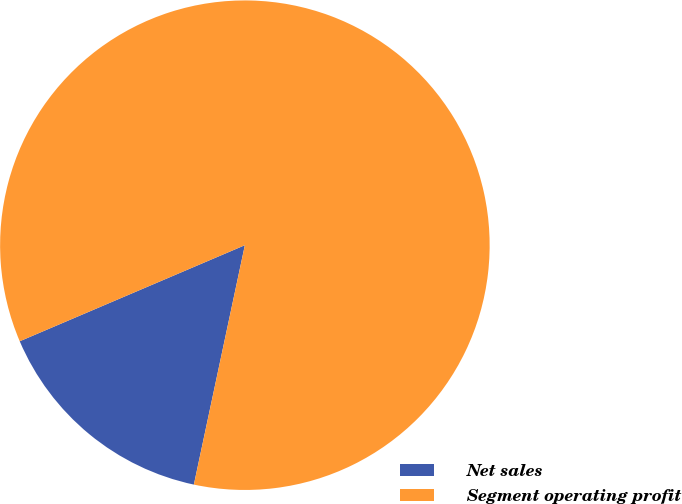Convert chart. <chart><loc_0><loc_0><loc_500><loc_500><pie_chart><fcel>Net sales<fcel>Segment operating profit<nl><fcel>15.24%<fcel>84.76%<nl></chart> 